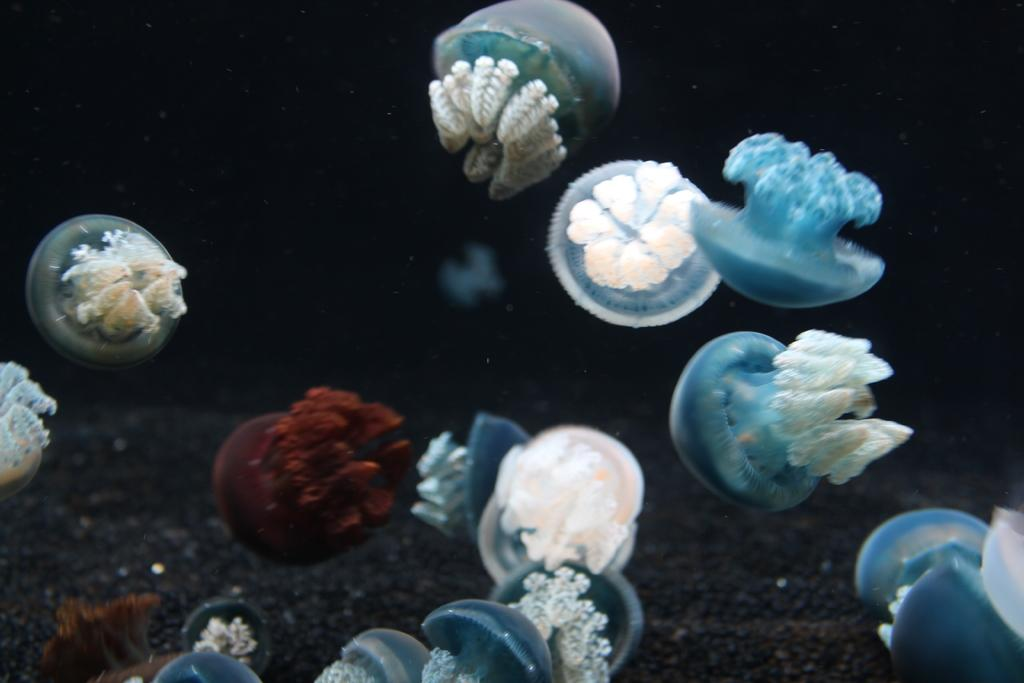What type of sea creatures are present in the image? There are jellyfish in the image. Can you describe the appearance of the jellyfish? The jellyfish have a translucent, gelatinous body and long, trailing tentacles. What is the primary setting of the image? The image is set in a body of water, likely an ocean or sea. What story does the owner of the jellyfish tell about their pet? There is no owner of the jellyfish mentioned in the image, and therefore no story can be attributed to them. 